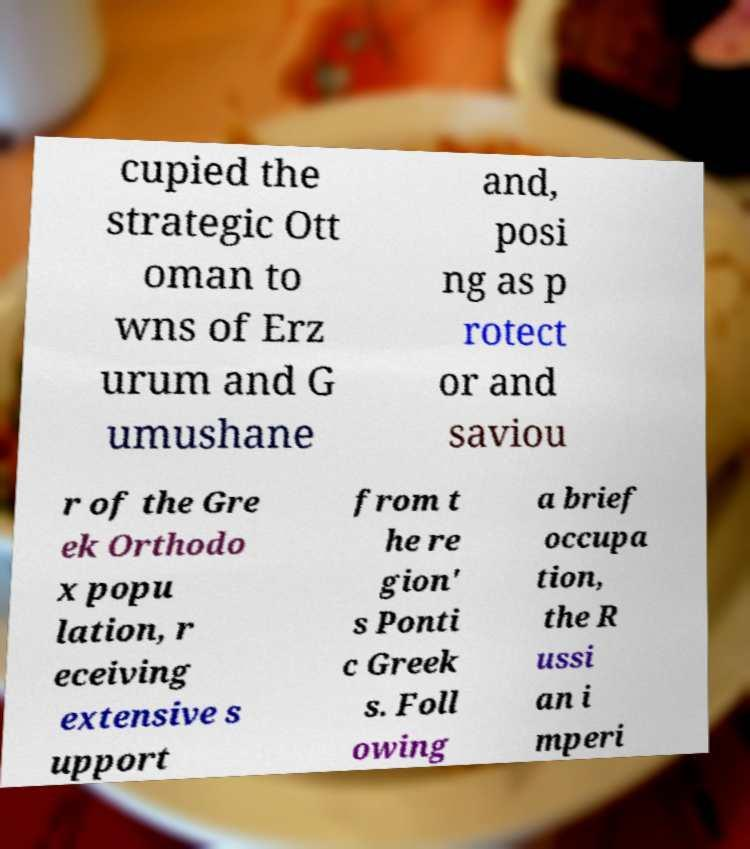Please read and relay the text visible in this image. What does it say? cupied the strategic Ott oman to wns of Erz urum and G umushane and, posi ng as p rotect or and saviou r of the Gre ek Orthodo x popu lation, r eceiving extensive s upport from t he re gion' s Ponti c Greek s. Foll owing a brief occupa tion, the R ussi an i mperi 